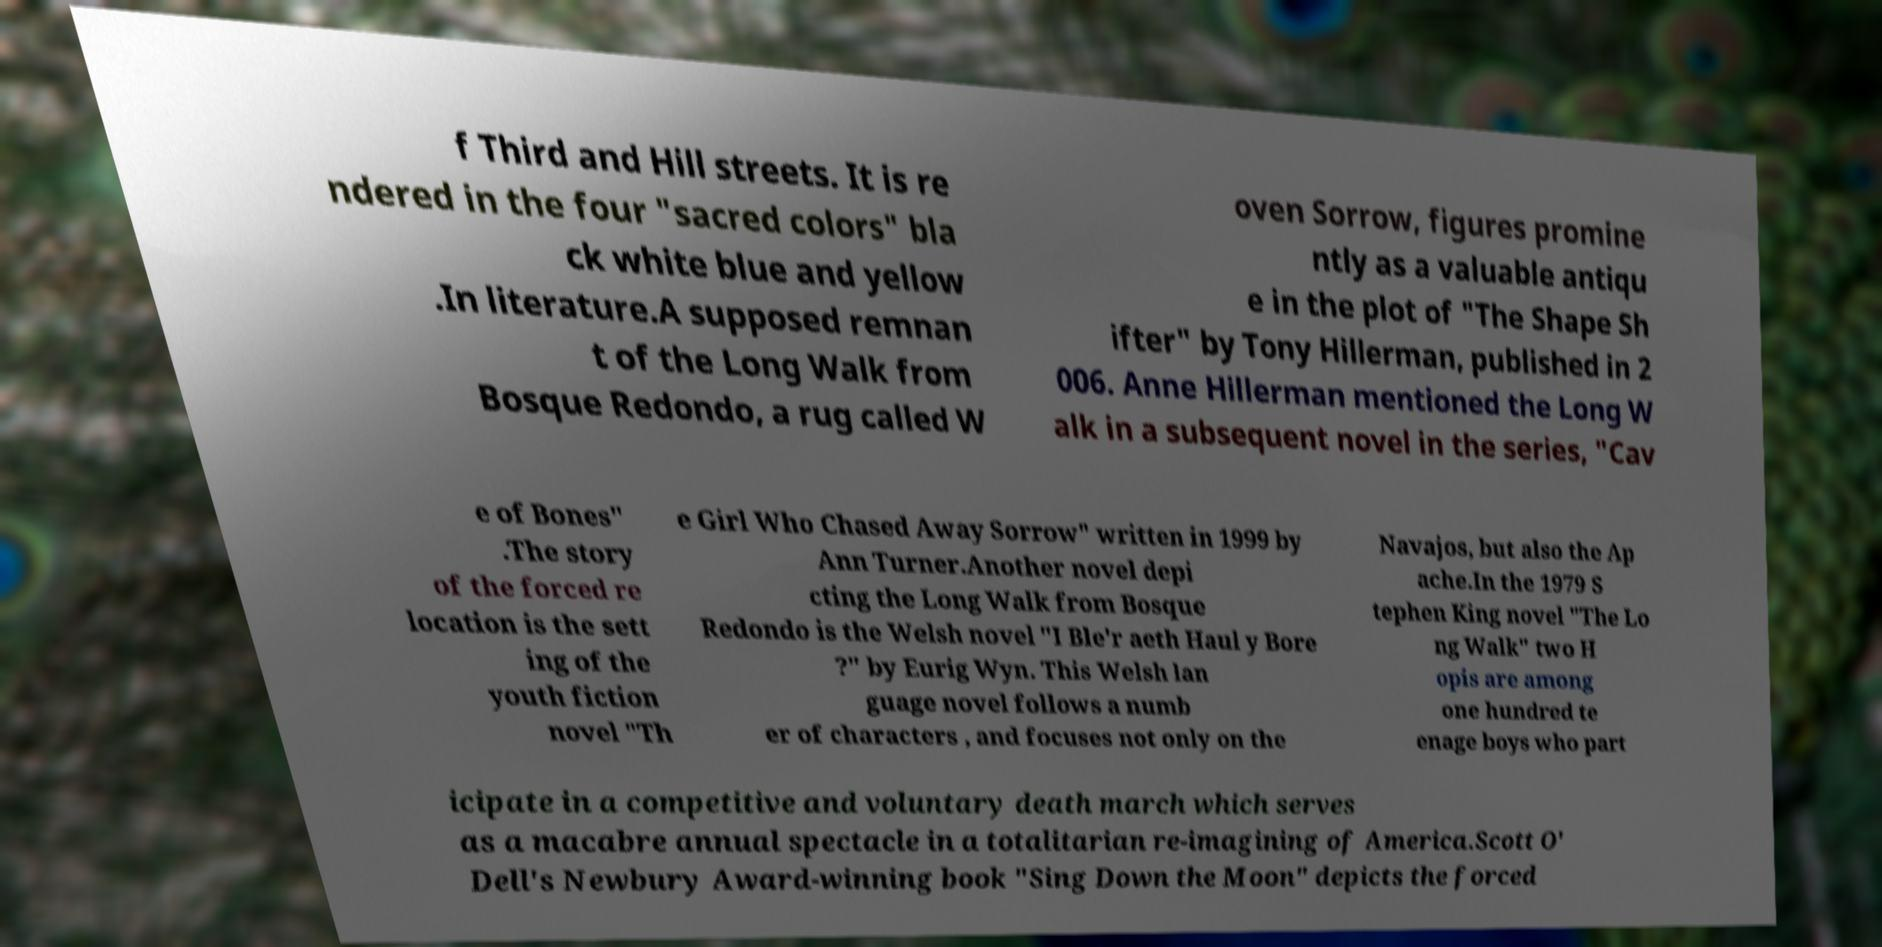What messages or text are displayed in this image? I need them in a readable, typed format. f Third and Hill streets. It is re ndered in the four "sacred colors" bla ck white blue and yellow .In literature.A supposed remnan t of the Long Walk from Bosque Redondo, a rug called W oven Sorrow, figures promine ntly as a valuable antiqu e in the plot of "The Shape Sh ifter" by Tony Hillerman, published in 2 006. Anne Hillerman mentioned the Long W alk in a subsequent novel in the series, "Cav e of Bones" .The story of the forced re location is the sett ing of the youth fiction novel "Th e Girl Who Chased Away Sorrow" written in 1999 by Ann Turner.Another novel depi cting the Long Walk from Bosque Redondo is the Welsh novel "I Ble'r aeth Haul y Bore ?" by Eurig Wyn. This Welsh lan guage novel follows a numb er of characters , and focuses not only on the Navajos, but also the Ap ache.In the 1979 S tephen King novel "The Lo ng Walk" two H opis are among one hundred te enage boys who part icipate in a competitive and voluntary death march which serves as a macabre annual spectacle in a totalitarian re-imagining of America.Scott O' Dell's Newbury Award-winning book "Sing Down the Moon" depicts the forced 